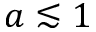<formula> <loc_0><loc_0><loc_500><loc_500>a \lesssim 1</formula> 